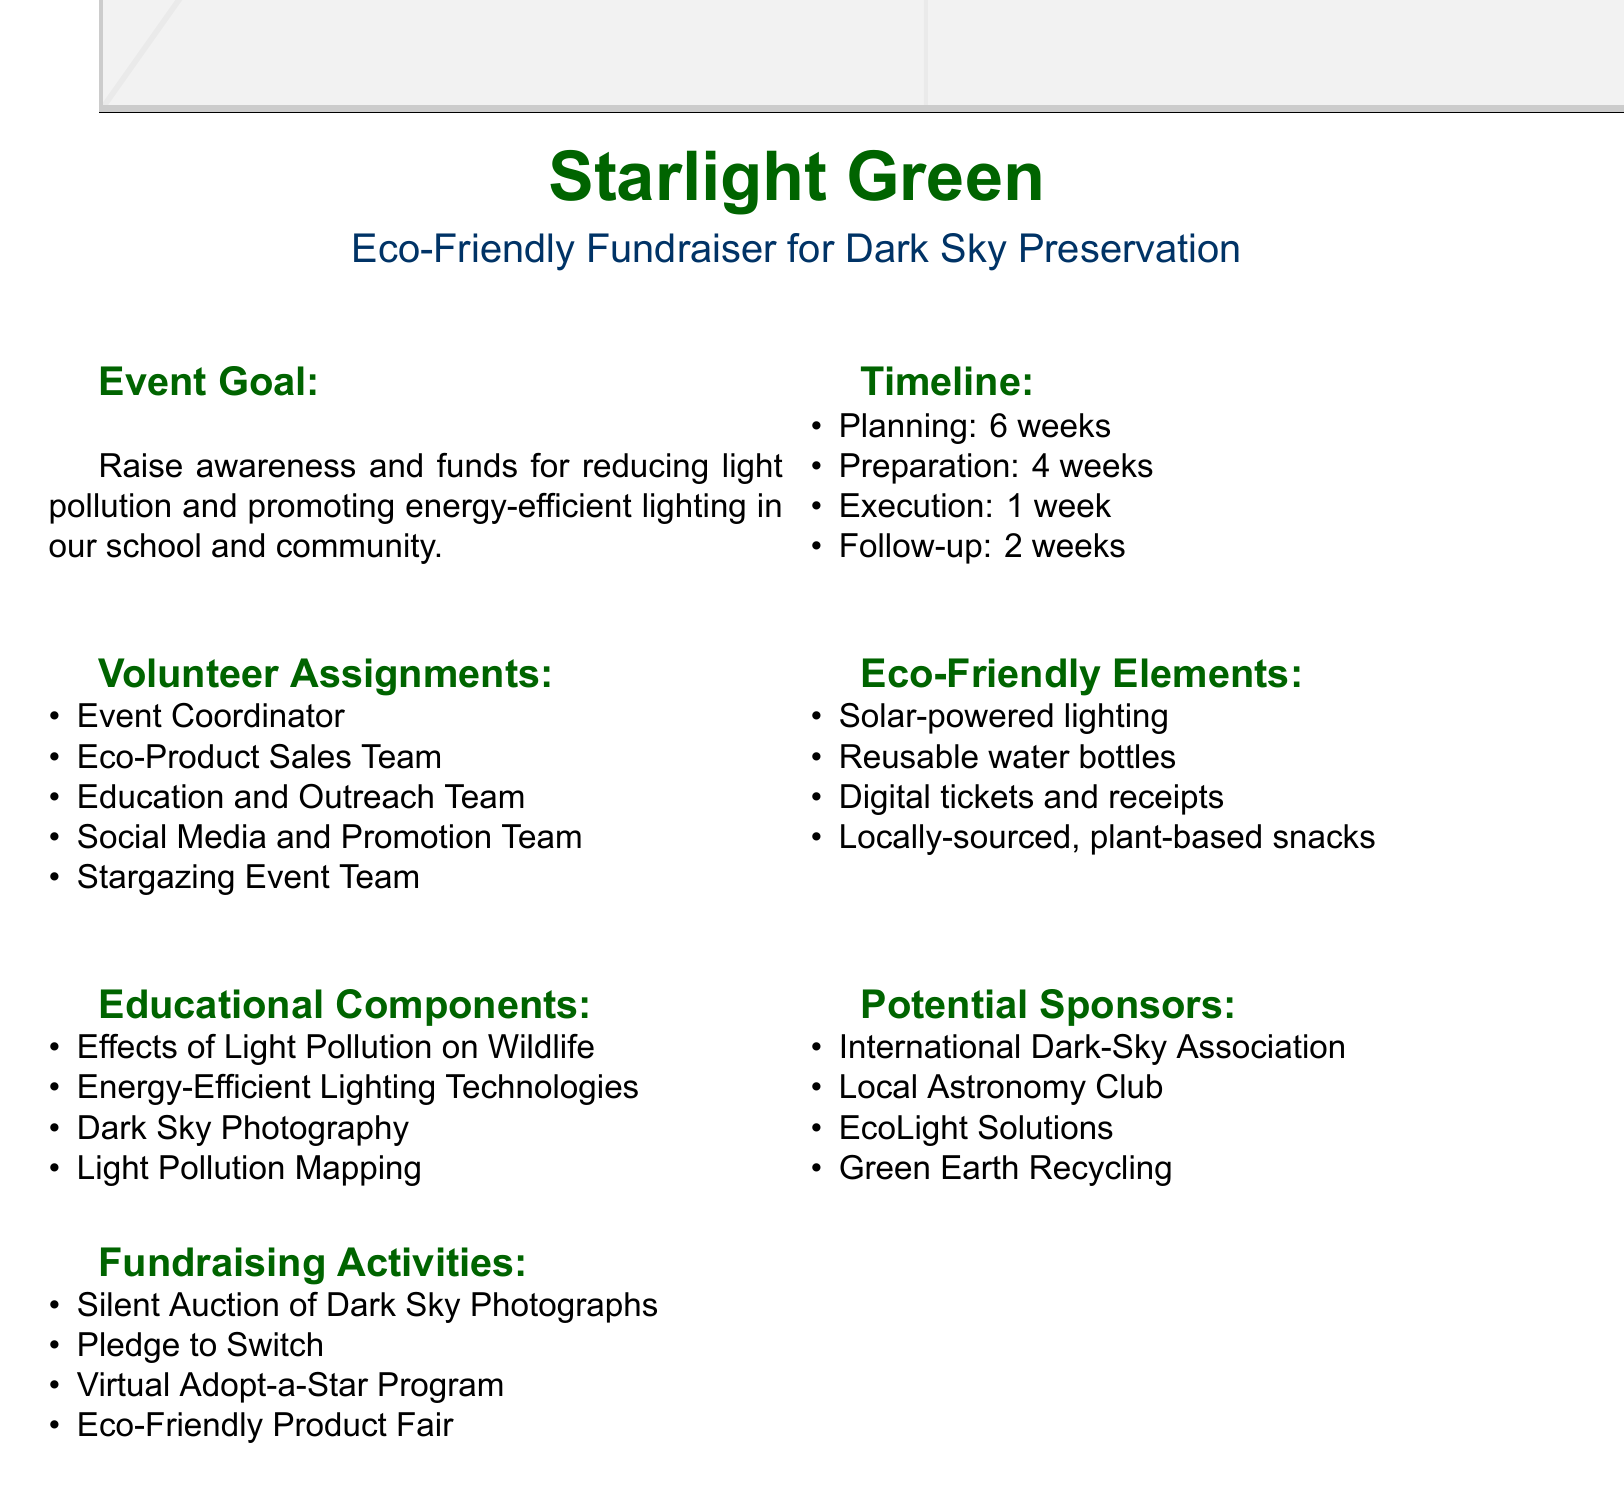What is the event name? The event name is stated at the beginning of the document, titled "Starlight Green."
Answer: Starlight Green How many weeks is the planning phase? The timeline section specifies the duration of the planning phase as 6 weeks.
Answer: 6 weeks Name one eco-friendly element included in the fundraiser. The document lists several eco-friendly elements, such as solar-powered lighting for the event space.
Answer: Solar-powered lighting Who is responsible for overseeing all aspects of the fundraiser? The volunteer assignments outline that the Event Coordinator oversees all aspects.
Answer: Event Coordinator What is one of the topics covered in the educational components? The educational components section includes topics, one of which is "Effects of Light Pollution on Wildlife."
Answer: Effects of Light Pollution on Wildlife How long is the preparation phase? The document states that the preparation phase lasts for 4 weeks.
Answer: 4 weeks Which team is responsible for promoting the event on social media? The Social Media and Promotion Team is assigned to manage social media content and promotions.
Answer: Social Media and Promotion Team What type of fundraising activity involves local astrophotographers? The Silent Auction of Dark Sky Photographs involves local astrophotographers who donate prints for auction.
Answer: Silent Auction of Dark Sky Photographs What is the goal of the event? The event goal is summarized as raising awareness and funds for reducing light pollution.
Answer: Raise awareness and funds for reducing light pollution 